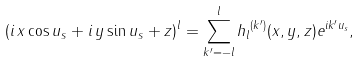Convert formula to latex. <formula><loc_0><loc_0><loc_500><loc_500>( i \, x \cos u _ { s } + i \, y \sin u _ { s } + z ) ^ { l } = \sum _ { k ^ { \prime } = - l } ^ { l } { h _ { l } } ^ { ( k ^ { \prime } ) } ( x , y , z ) e ^ { i k ^ { \prime } u _ { s } } ,</formula> 